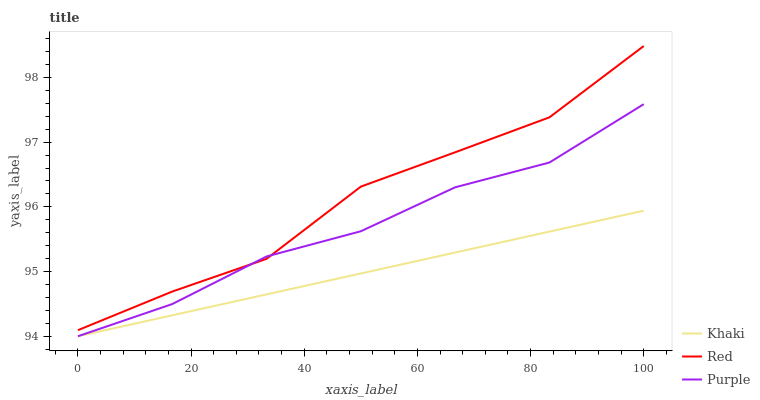Does Khaki have the minimum area under the curve?
Answer yes or no. Yes. Does Red have the maximum area under the curve?
Answer yes or no. Yes. Does Red have the minimum area under the curve?
Answer yes or no. No. Does Khaki have the maximum area under the curve?
Answer yes or no. No. Is Khaki the smoothest?
Answer yes or no. Yes. Is Red the roughest?
Answer yes or no. Yes. Is Red the smoothest?
Answer yes or no. No. Is Khaki the roughest?
Answer yes or no. No. Does Red have the lowest value?
Answer yes or no. No. Does Red have the highest value?
Answer yes or no. Yes. Does Khaki have the highest value?
Answer yes or no. No. Is Khaki less than Red?
Answer yes or no. Yes. Is Red greater than Khaki?
Answer yes or no. Yes. Does Purple intersect Red?
Answer yes or no. Yes. Is Purple less than Red?
Answer yes or no. No. Is Purple greater than Red?
Answer yes or no. No. Does Khaki intersect Red?
Answer yes or no. No. 